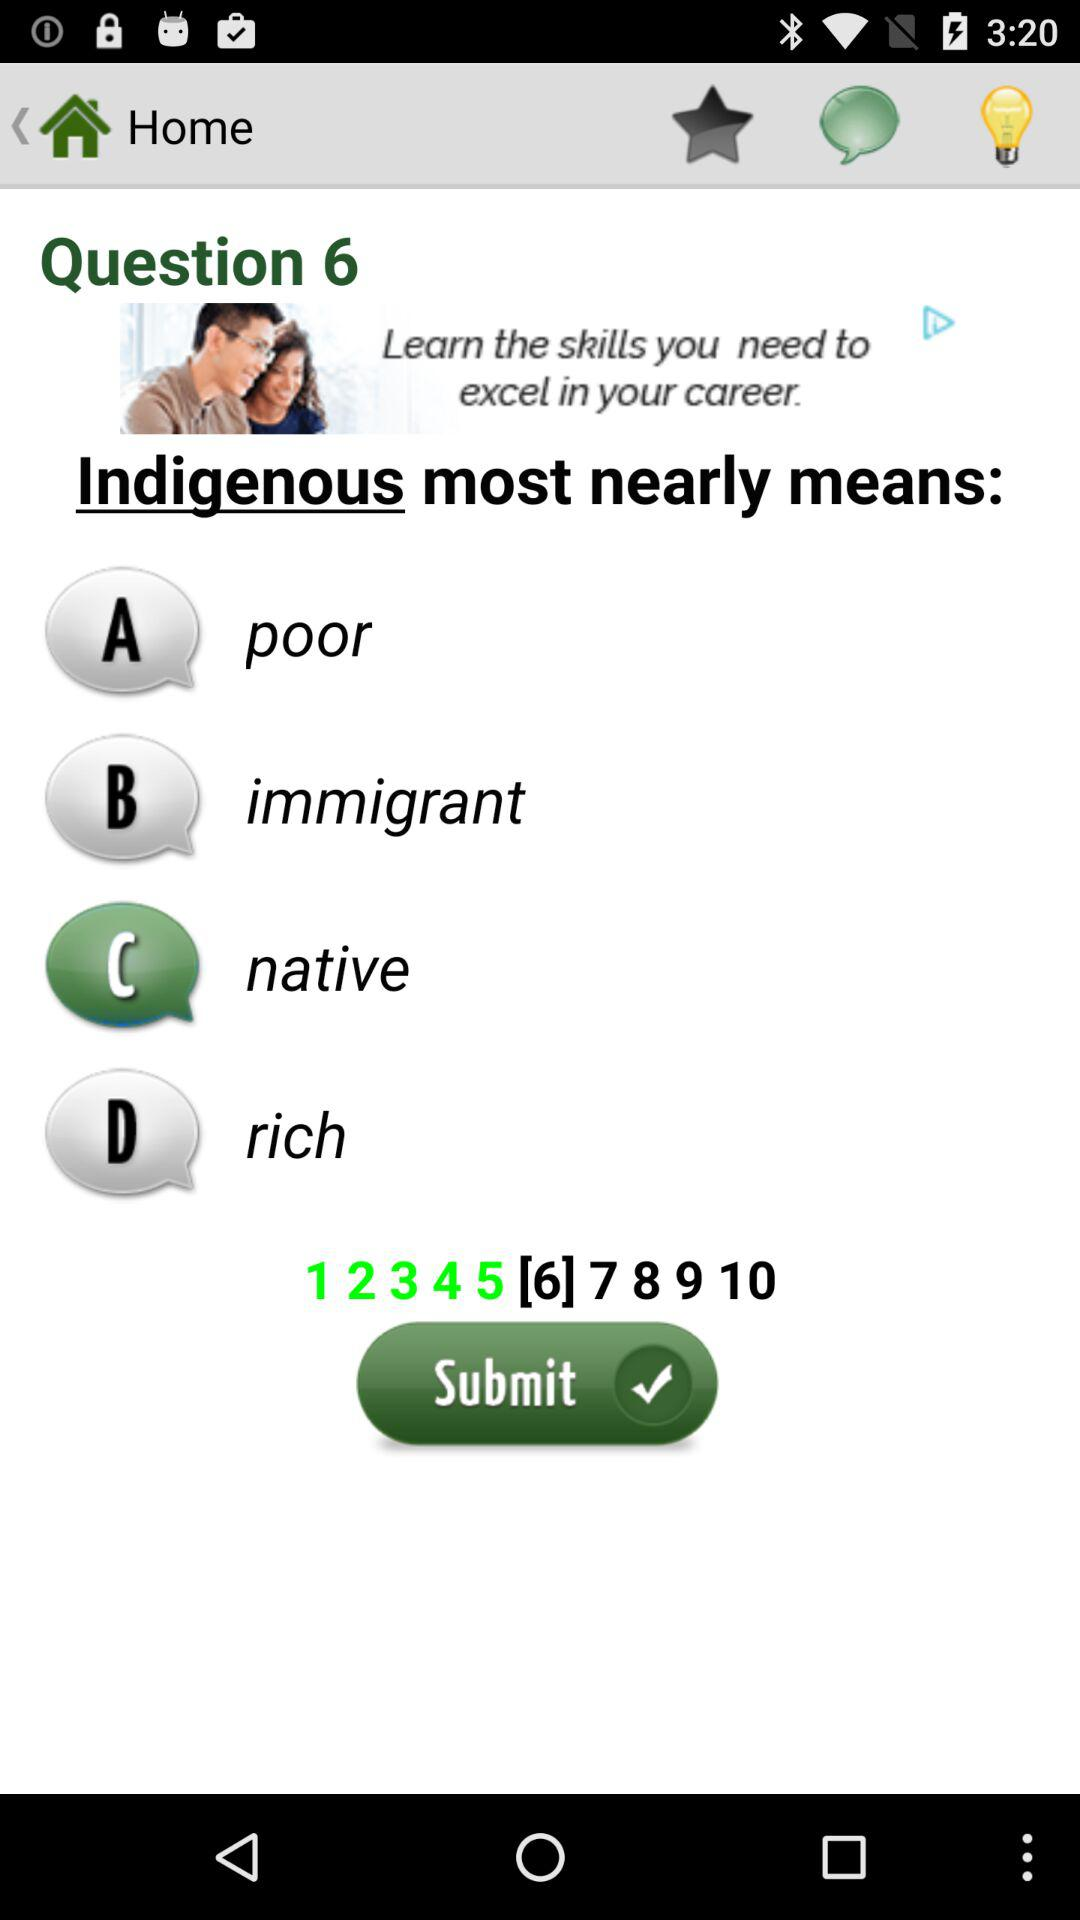Which is the selected answer for the current question? The selected answer is "native". 